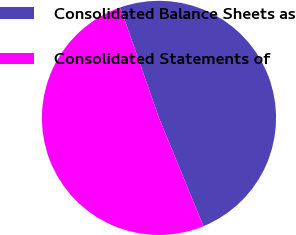Convert chart to OTSL. <chart><loc_0><loc_0><loc_500><loc_500><pie_chart><fcel>Consolidated Balance Sheets as<fcel>Consolidated Statements of<nl><fcel>49.15%<fcel>50.85%<nl></chart> 